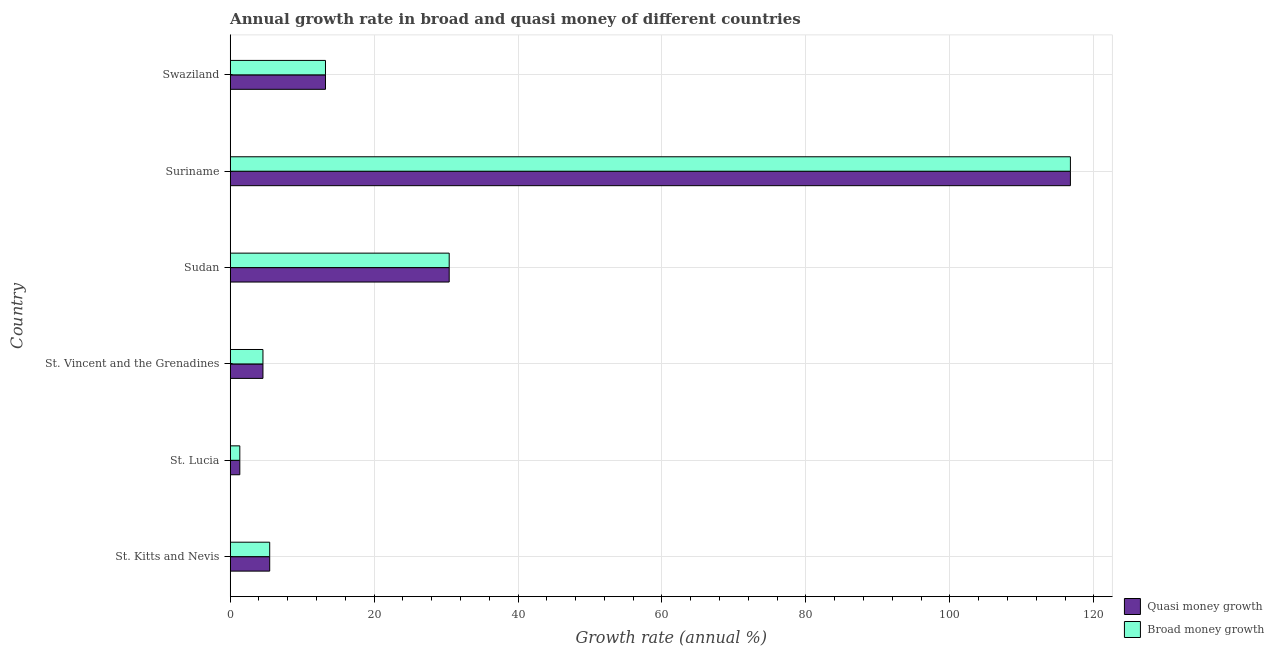How many different coloured bars are there?
Make the answer very short. 2. How many groups of bars are there?
Ensure brevity in your answer.  6. Are the number of bars per tick equal to the number of legend labels?
Offer a very short reply. Yes. How many bars are there on the 4th tick from the bottom?
Your answer should be very brief. 2. What is the label of the 1st group of bars from the top?
Keep it short and to the point. Swaziland. In how many cases, is the number of bars for a given country not equal to the number of legend labels?
Make the answer very short. 0. What is the annual growth rate in quasi money in Sudan?
Ensure brevity in your answer.  30.43. Across all countries, what is the maximum annual growth rate in quasi money?
Your answer should be compact. 116.75. Across all countries, what is the minimum annual growth rate in quasi money?
Make the answer very short. 1.34. In which country was the annual growth rate in broad money maximum?
Provide a succinct answer. Suriname. In which country was the annual growth rate in broad money minimum?
Keep it short and to the point. St. Lucia. What is the total annual growth rate in quasi money in the graph?
Give a very brief answer. 171.81. What is the difference between the annual growth rate in quasi money in St. Lucia and that in Suriname?
Make the answer very short. -115.42. What is the difference between the annual growth rate in quasi money in St. Kitts and Nevis and the annual growth rate in broad money in St. Lucia?
Offer a very short reply. 4.16. What is the average annual growth rate in broad money per country?
Offer a very short reply. 28.64. What is the ratio of the annual growth rate in quasi money in Sudan to that in Swaziland?
Provide a short and direct response. 2.3. What is the difference between the highest and the second highest annual growth rate in quasi money?
Your answer should be very brief. 86.32. What is the difference between the highest and the lowest annual growth rate in broad money?
Your response must be concise. 115.41. In how many countries, is the annual growth rate in broad money greater than the average annual growth rate in broad money taken over all countries?
Your response must be concise. 2. Is the sum of the annual growth rate in broad money in Sudan and Swaziland greater than the maximum annual growth rate in quasi money across all countries?
Ensure brevity in your answer.  No. What does the 2nd bar from the top in Suriname represents?
Offer a very short reply. Quasi money growth. What does the 2nd bar from the bottom in St. Lucia represents?
Offer a very short reply. Broad money growth. How many bars are there?
Keep it short and to the point. 12. What is the difference between two consecutive major ticks on the X-axis?
Make the answer very short. 20. Are the values on the major ticks of X-axis written in scientific E-notation?
Your response must be concise. No. Does the graph contain grids?
Make the answer very short. Yes. Where does the legend appear in the graph?
Offer a terse response. Bottom right. What is the title of the graph?
Keep it short and to the point. Annual growth rate in broad and quasi money of different countries. Does "Non-residents" appear as one of the legend labels in the graph?
Your response must be concise. No. What is the label or title of the X-axis?
Your answer should be very brief. Growth rate (annual %). What is the Growth rate (annual %) of Quasi money growth in St. Kitts and Nevis?
Your response must be concise. 5.49. What is the Growth rate (annual %) of Broad money growth in St. Kitts and Nevis?
Your answer should be very brief. 5.49. What is the Growth rate (annual %) in Quasi money growth in St. Lucia?
Your response must be concise. 1.34. What is the Growth rate (annual %) of Broad money growth in St. Lucia?
Ensure brevity in your answer.  1.34. What is the Growth rate (annual %) of Quasi money growth in St. Vincent and the Grenadines?
Ensure brevity in your answer.  4.55. What is the Growth rate (annual %) in Broad money growth in St. Vincent and the Grenadines?
Ensure brevity in your answer.  4.55. What is the Growth rate (annual %) in Quasi money growth in Sudan?
Your response must be concise. 30.43. What is the Growth rate (annual %) of Broad money growth in Sudan?
Keep it short and to the point. 30.43. What is the Growth rate (annual %) in Quasi money growth in Suriname?
Offer a very short reply. 116.75. What is the Growth rate (annual %) in Broad money growth in Suriname?
Your answer should be very brief. 116.75. What is the Growth rate (annual %) of Quasi money growth in Swaziland?
Provide a short and direct response. 13.24. What is the Growth rate (annual %) of Broad money growth in Swaziland?
Make the answer very short. 13.24. Across all countries, what is the maximum Growth rate (annual %) in Quasi money growth?
Give a very brief answer. 116.75. Across all countries, what is the maximum Growth rate (annual %) of Broad money growth?
Your response must be concise. 116.75. Across all countries, what is the minimum Growth rate (annual %) in Quasi money growth?
Make the answer very short. 1.34. Across all countries, what is the minimum Growth rate (annual %) in Broad money growth?
Your response must be concise. 1.34. What is the total Growth rate (annual %) in Quasi money growth in the graph?
Keep it short and to the point. 171.81. What is the total Growth rate (annual %) in Broad money growth in the graph?
Ensure brevity in your answer.  171.81. What is the difference between the Growth rate (annual %) of Quasi money growth in St. Kitts and Nevis and that in St. Lucia?
Offer a very short reply. 4.16. What is the difference between the Growth rate (annual %) in Broad money growth in St. Kitts and Nevis and that in St. Lucia?
Provide a short and direct response. 4.16. What is the difference between the Growth rate (annual %) of Quasi money growth in St. Kitts and Nevis and that in St. Vincent and the Grenadines?
Your answer should be compact. 0.94. What is the difference between the Growth rate (annual %) in Broad money growth in St. Kitts and Nevis and that in St. Vincent and the Grenadines?
Ensure brevity in your answer.  0.94. What is the difference between the Growth rate (annual %) in Quasi money growth in St. Kitts and Nevis and that in Sudan?
Provide a succinct answer. -24.94. What is the difference between the Growth rate (annual %) in Broad money growth in St. Kitts and Nevis and that in Sudan?
Provide a succinct answer. -24.94. What is the difference between the Growth rate (annual %) in Quasi money growth in St. Kitts and Nevis and that in Suriname?
Provide a succinct answer. -111.26. What is the difference between the Growth rate (annual %) of Broad money growth in St. Kitts and Nevis and that in Suriname?
Provide a short and direct response. -111.26. What is the difference between the Growth rate (annual %) of Quasi money growth in St. Kitts and Nevis and that in Swaziland?
Your answer should be compact. -7.75. What is the difference between the Growth rate (annual %) of Broad money growth in St. Kitts and Nevis and that in Swaziland?
Provide a succinct answer. -7.75. What is the difference between the Growth rate (annual %) in Quasi money growth in St. Lucia and that in St. Vincent and the Grenadines?
Make the answer very short. -3.22. What is the difference between the Growth rate (annual %) of Broad money growth in St. Lucia and that in St. Vincent and the Grenadines?
Provide a succinct answer. -3.22. What is the difference between the Growth rate (annual %) in Quasi money growth in St. Lucia and that in Sudan?
Your answer should be compact. -29.1. What is the difference between the Growth rate (annual %) in Broad money growth in St. Lucia and that in Sudan?
Your response must be concise. -29.1. What is the difference between the Growth rate (annual %) in Quasi money growth in St. Lucia and that in Suriname?
Keep it short and to the point. -115.42. What is the difference between the Growth rate (annual %) of Broad money growth in St. Lucia and that in Suriname?
Offer a very short reply. -115.42. What is the difference between the Growth rate (annual %) in Quasi money growth in St. Lucia and that in Swaziland?
Ensure brevity in your answer.  -11.9. What is the difference between the Growth rate (annual %) of Broad money growth in St. Lucia and that in Swaziland?
Ensure brevity in your answer.  -11.9. What is the difference between the Growth rate (annual %) of Quasi money growth in St. Vincent and the Grenadines and that in Sudan?
Give a very brief answer. -25.88. What is the difference between the Growth rate (annual %) of Broad money growth in St. Vincent and the Grenadines and that in Sudan?
Give a very brief answer. -25.88. What is the difference between the Growth rate (annual %) in Quasi money growth in St. Vincent and the Grenadines and that in Suriname?
Your answer should be very brief. -112.2. What is the difference between the Growth rate (annual %) in Broad money growth in St. Vincent and the Grenadines and that in Suriname?
Make the answer very short. -112.2. What is the difference between the Growth rate (annual %) of Quasi money growth in St. Vincent and the Grenadines and that in Swaziland?
Your response must be concise. -8.69. What is the difference between the Growth rate (annual %) of Broad money growth in St. Vincent and the Grenadines and that in Swaziland?
Make the answer very short. -8.69. What is the difference between the Growth rate (annual %) of Quasi money growth in Sudan and that in Suriname?
Your answer should be very brief. -86.32. What is the difference between the Growth rate (annual %) in Broad money growth in Sudan and that in Suriname?
Make the answer very short. -86.32. What is the difference between the Growth rate (annual %) of Quasi money growth in Sudan and that in Swaziland?
Give a very brief answer. 17.19. What is the difference between the Growth rate (annual %) in Broad money growth in Sudan and that in Swaziland?
Make the answer very short. 17.19. What is the difference between the Growth rate (annual %) in Quasi money growth in Suriname and that in Swaziland?
Keep it short and to the point. 103.51. What is the difference between the Growth rate (annual %) of Broad money growth in Suriname and that in Swaziland?
Give a very brief answer. 103.51. What is the difference between the Growth rate (annual %) in Quasi money growth in St. Kitts and Nevis and the Growth rate (annual %) in Broad money growth in St. Lucia?
Ensure brevity in your answer.  4.16. What is the difference between the Growth rate (annual %) in Quasi money growth in St. Kitts and Nevis and the Growth rate (annual %) in Broad money growth in St. Vincent and the Grenadines?
Provide a succinct answer. 0.94. What is the difference between the Growth rate (annual %) of Quasi money growth in St. Kitts and Nevis and the Growth rate (annual %) of Broad money growth in Sudan?
Provide a succinct answer. -24.94. What is the difference between the Growth rate (annual %) in Quasi money growth in St. Kitts and Nevis and the Growth rate (annual %) in Broad money growth in Suriname?
Make the answer very short. -111.26. What is the difference between the Growth rate (annual %) in Quasi money growth in St. Kitts and Nevis and the Growth rate (annual %) in Broad money growth in Swaziland?
Your answer should be compact. -7.75. What is the difference between the Growth rate (annual %) of Quasi money growth in St. Lucia and the Growth rate (annual %) of Broad money growth in St. Vincent and the Grenadines?
Provide a succinct answer. -3.22. What is the difference between the Growth rate (annual %) of Quasi money growth in St. Lucia and the Growth rate (annual %) of Broad money growth in Sudan?
Your response must be concise. -29.1. What is the difference between the Growth rate (annual %) of Quasi money growth in St. Lucia and the Growth rate (annual %) of Broad money growth in Suriname?
Provide a succinct answer. -115.42. What is the difference between the Growth rate (annual %) of Quasi money growth in St. Lucia and the Growth rate (annual %) of Broad money growth in Swaziland?
Provide a succinct answer. -11.9. What is the difference between the Growth rate (annual %) of Quasi money growth in St. Vincent and the Grenadines and the Growth rate (annual %) of Broad money growth in Sudan?
Provide a short and direct response. -25.88. What is the difference between the Growth rate (annual %) of Quasi money growth in St. Vincent and the Grenadines and the Growth rate (annual %) of Broad money growth in Suriname?
Ensure brevity in your answer.  -112.2. What is the difference between the Growth rate (annual %) of Quasi money growth in St. Vincent and the Grenadines and the Growth rate (annual %) of Broad money growth in Swaziland?
Offer a very short reply. -8.69. What is the difference between the Growth rate (annual %) in Quasi money growth in Sudan and the Growth rate (annual %) in Broad money growth in Suriname?
Your response must be concise. -86.32. What is the difference between the Growth rate (annual %) of Quasi money growth in Sudan and the Growth rate (annual %) of Broad money growth in Swaziland?
Your answer should be compact. 17.19. What is the difference between the Growth rate (annual %) in Quasi money growth in Suriname and the Growth rate (annual %) in Broad money growth in Swaziland?
Ensure brevity in your answer.  103.51. What is the average Growth rate (annual %) of Quasi money growth per country?
Your answer should be very brief. 28.63. What is the average Growth rate (annual %) in Broad money growth per country?
Ensure brevity in your answer.  28.63. What is the difference between the Growth rate (annual %) in Quasi money growth and Growth rate (annual %) in Broad money growth in St. Kitts and Nevis?
Ensure brevity in your answer.  0. What is the difference between the Growth rate (annual %) in Quasi money growth and Growth rate (annual %) in Broad money growth in St. Lucia?
Your answer should be compact. 0. What is the difference between the Growth rate (annual %) in Quasi money growth and Growth rate (annual %) in Broad money growth in St. Vincent and the Grenadines?
Your answer should be very brief. 0. What is the difference between the Growth rate (annual %) in Quasi money growth and Growth rate (annual %) in Broad money growth in Sudan?
Make the answer very short. 0. What is the difference between the Growth rate (annual %) in Quasi money growth and Growth rate (annual %) in Broad money growth in Suriname?
Your answer should be compact. 0. What is the ratio of the Growth rate (annual %) in Quasi money growth in St. Kitts and Nevis to that in St. Lucia?
Your answer should be compact. 4.11. What is the ratio of the Growth rate (annual %) in Broad money growth in St. Kitts and Nevis to that in St. Lucia?
Offer a very short reply. 4.11. What is the ratio of the Growth rate (annual %) of Quasi money growth in St. Kitts and Nevis to that in St. Vincent and the Grenadines?
Your answer should be compact. 1.21. What is the ratio of the Growth rate (annual %) of Broad money growth in St. Kitts and Nevis to that in St. Vincent and the Grenadines?
Ensure brevity in your answer.  1.21. What is the ratio of the Growth rate (annual %) of Quasi money growth in St. Kitts and Nevis to that in Sudan?
Offer a terse response. 0.18. What is the ratio of the Growth rate (annual %) in Broad money growth in St. Kitts and Nevis to that in Sudan?
Offer a terse response. 0.18. What is the ratio of the Growth rate (annual %) of Quasi money growth in St. Kitts and Nevis to that in Suriname?
Provide a short and direct response. 0.05. What is the ratio of the Growth rate (annual %) of Broad money growth in St. Kitts and Nevis to that in Suriname?
Provide a short and direct response. 0.05. What is the ratio of the Growth rate (annual %) in Quasi money growth in St. Kitts and Nevis to that in Swaziland?
Provide a succinct answer. 0.41. What is the ratio of the Growth rate (annual %) of Broad money growth in St. Kitts and Nevis to that in Swaziland?
Your response must be concise. 0.41. What is the ratio of the Growth rate (annual %) of Quasi money growth in St. Lucia to that in St. Vincent and the Grenadines?
Your answer should be very brief. 0.29. What is the ratio of the Growth rate (annual %) of Broad money growth in St. Lucia to that in St. Vincent and the Grenadines?
Offer a very short reply. 0.29. What is the ratio of the Growth rate (annual %) in Quasi money growth in St. Lucia to that in Sudan?
Make the answer very short. 0.04. What is the ratio of the Growth rate (annual %) of Broad money growth in St. Lucia to that in Sudan?
Offer a very short reply. 0.04. What is the ratio of the Growth rate (annual %) of Quasi money growth in St. Lucia to that in Suriname?
Offer a terse response. 0.01. What is the ratio of the Growth rate (annual %) in Broad money growth in St. Lucia to that in Suriname?
Your response must be concise. 0.01. What is the ratio of the Growth rate (annual %) of Quasi money growth in St. Lucia to that in Swaziland?
Ensure brevity in your answer.  0.1. What is the ratio of the Growth rate (annual %) in Broad money growth in St. Lucia to that in Swaziland?
Make the answer very short. 0.1. What is the ratio of the Growth rate (annual %) of Quasi money growth in St. Vincent and the Grenadines to that in Sudan?
Give a very brief answer. 0.15. What is the ratio of the Growth rate (annual %) in Broad money growth in St. Vincent and the Grenadines to that in Sudan?
Give a very brief answer. 0.15. What is the ratio of the Growth rate (annual %) in Quasi money growth in St. Vincent and the Grenadines to that in Suriname?
Your answer should be very brief. 0.04. What is the ratio of the Growth rate (annual %) in Broad money growth in St. Vincent and the Grenadines to that in Suriname?
Your answer should be very brief. 0.04. What is the ratio of the Growth rate (annual %) in Quasi money growth in St. Vincent and the Grenadines to that in Swaziland?
Your answer should be very brief. 0.34. What is the ratio of the Growth rate (annual %) of Broad money growth in St. Vincent and the Grenadines to that in Swaziland?
Give a very brief answer. 0.34. What is the ratio of the Growth rate (annual %) of Quasi money growth in Sudan to that in Suriname?
Your answer should be very brief. 0.26. What is the ratio of the Growth rate (annual %) in Broad money growth in Sudan to that in Suriname?
Your response must be concise. 0.26. What is the ratio of the Growth rate (annual %) of Quasi money growth in Sudan to that in Swaziland?
Ensure brevity in your answer.  2.3. What is the ratio of the Growth rate (annual %) in Broad money growth in Sudan to that in Swaziland?
Your answer should be compact. 2.3. What is the ratio of the Growth rate (annual %) in Quasi money growth in Suriname to that in Swaziland?
Give a very brief answer. 8.82. What is the ratio of the Growth rate (annual %) in Broad money growth in Suriname to that in Swaziland?
Your answer should be very brief. 8.82. What is the difference between the highest and the second highest Growth rate (annual %) in Quasi money growth?
Keep it short and to the point. 86.32. What is the difference between the highest and the second highest Growth rate (annual %) of Broad money growth?
Make the answer very short. 86.32. What is the difference between the highest and the lowest Growth rate (annual %) of Quasi money growth?
Keep it short and to the point. 115.42. What is the difference between the highest and the lowest Growth rate (annual %) of Broad money growth?
Keep it short and to the point. 115.42. 